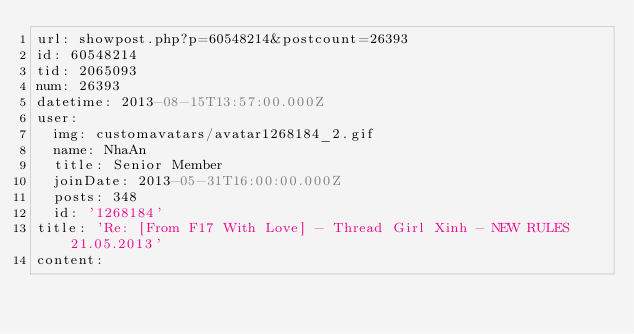Convert code to text. <code><loc_0><loc_0><loc_500><loc_500><_YAML_>url: showpost.php?p=60548214&postcount=26393
id: 60548214
tid: 2065093
num: 26393
datetime: 2013-08-15T13:57:00.000Z
user:
  img: customavatars/avatar1268184_2.gif
  name: NhaAn
  title: Senior Member
  joinDate: 2013-05-31T16:00:00.000Z
  posts: 348
  id: '1268184'
title: 'Re: [From F17 With Love] - Thread Girl Xinh - NEW RULES 21.05.2013'
content:</code> 